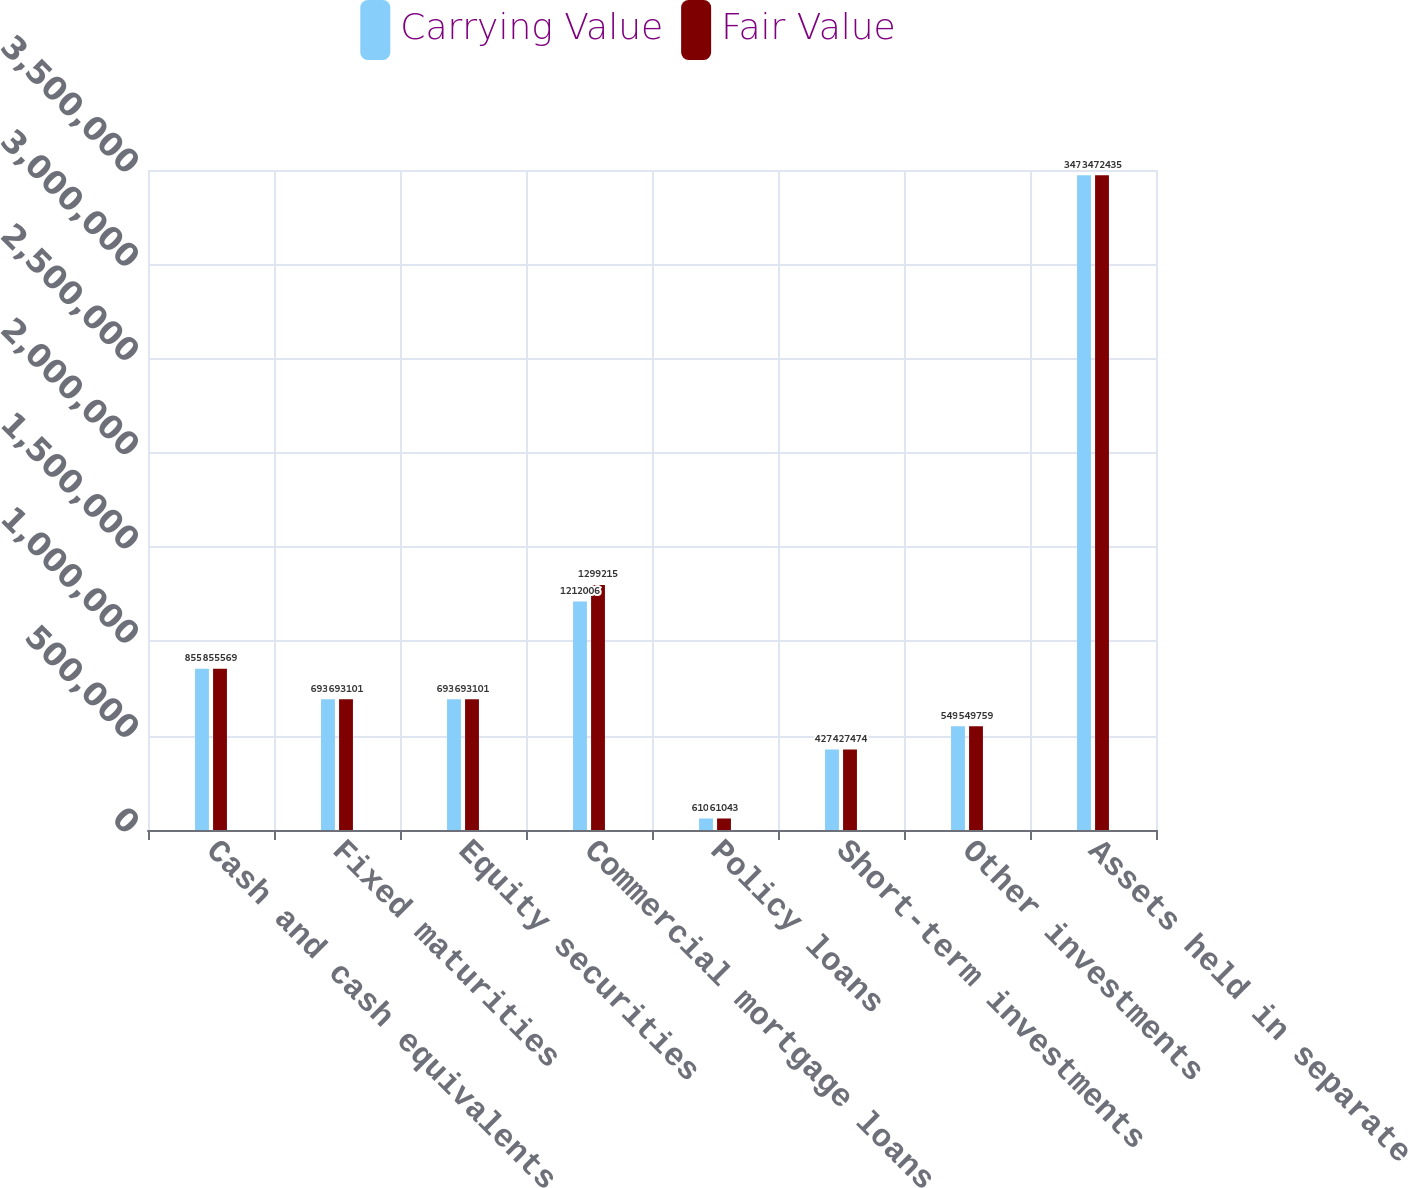Convert chart. <chart><loc_0><loc_0><loc_500><loc_500><stacked_bar_chart><ecel><fcel>Cash and cash equivalents<fcel>Fixed maturities<fcel>Equity securities<fcel>Commercial mortgage loans on<fcel>Policy loans<fcel>Short-term investments<fcel>Other investments<fcel>Assets held in separate<nl><fcel>Carrying Value<fcel>855569<fcel>693101<fcel>693101<fcel>1.21201e+06<fcel>61043<fcel>427474<fcel>549759<fcel>3.47244e+06<nl><fcel>Fair Value<fcel>855569<fcel>693101<fcel>693101<fcel>1.29922e+06<fcel>61043<fcel>427474<fcel>549759<fcel>3.47244e+06<nl></chart> 